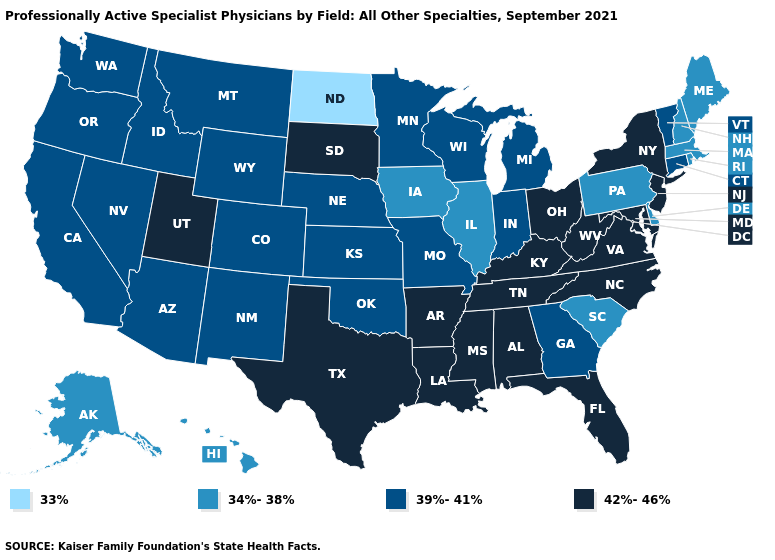Among the states that border New Mexico , does Utah have the lowest value?
Concise answer only. No. Name the states that have a value in the range 34%-38%?
Answer briefly. Alaska, Delaware, Hawaii, Illinois, Iowa, Maine, Massachusetts, New Hampshire, Pennsylvania, Rhode Island, South Carolina. Which states have the lowest value in the South?
Be succinct. Delaware, South Carolina. Is the legend a continuous bar?
Short answer required. No. What is the value of Mississippi?
Quick response, please. 42%-46%. How many symbols are there in the legend?
Answer briefly. 4. What is the value of South Carolina?
Answer briefly. 34%-38%. What is the lowest value in the West?
Be succinct. 34%-38%. Does the first symbol in the legend represent the smallest category?
Short answer required. Yes. What is the value of Texas?
Quick response, please. 42%-46%. Does Arkansas have the same value as Massachusetts?
Quick response, please. No. What is the highest value in the Northeast ?
Write a very short answer. 42%-46%. Name the states that have a value in the range 33%?
Be succinct. North Dakota. What is the lowest value in states that border West Virginia?
Short answer required. 34%-38%. How many symbols are there in the legend?
Quick response, please. 4. 